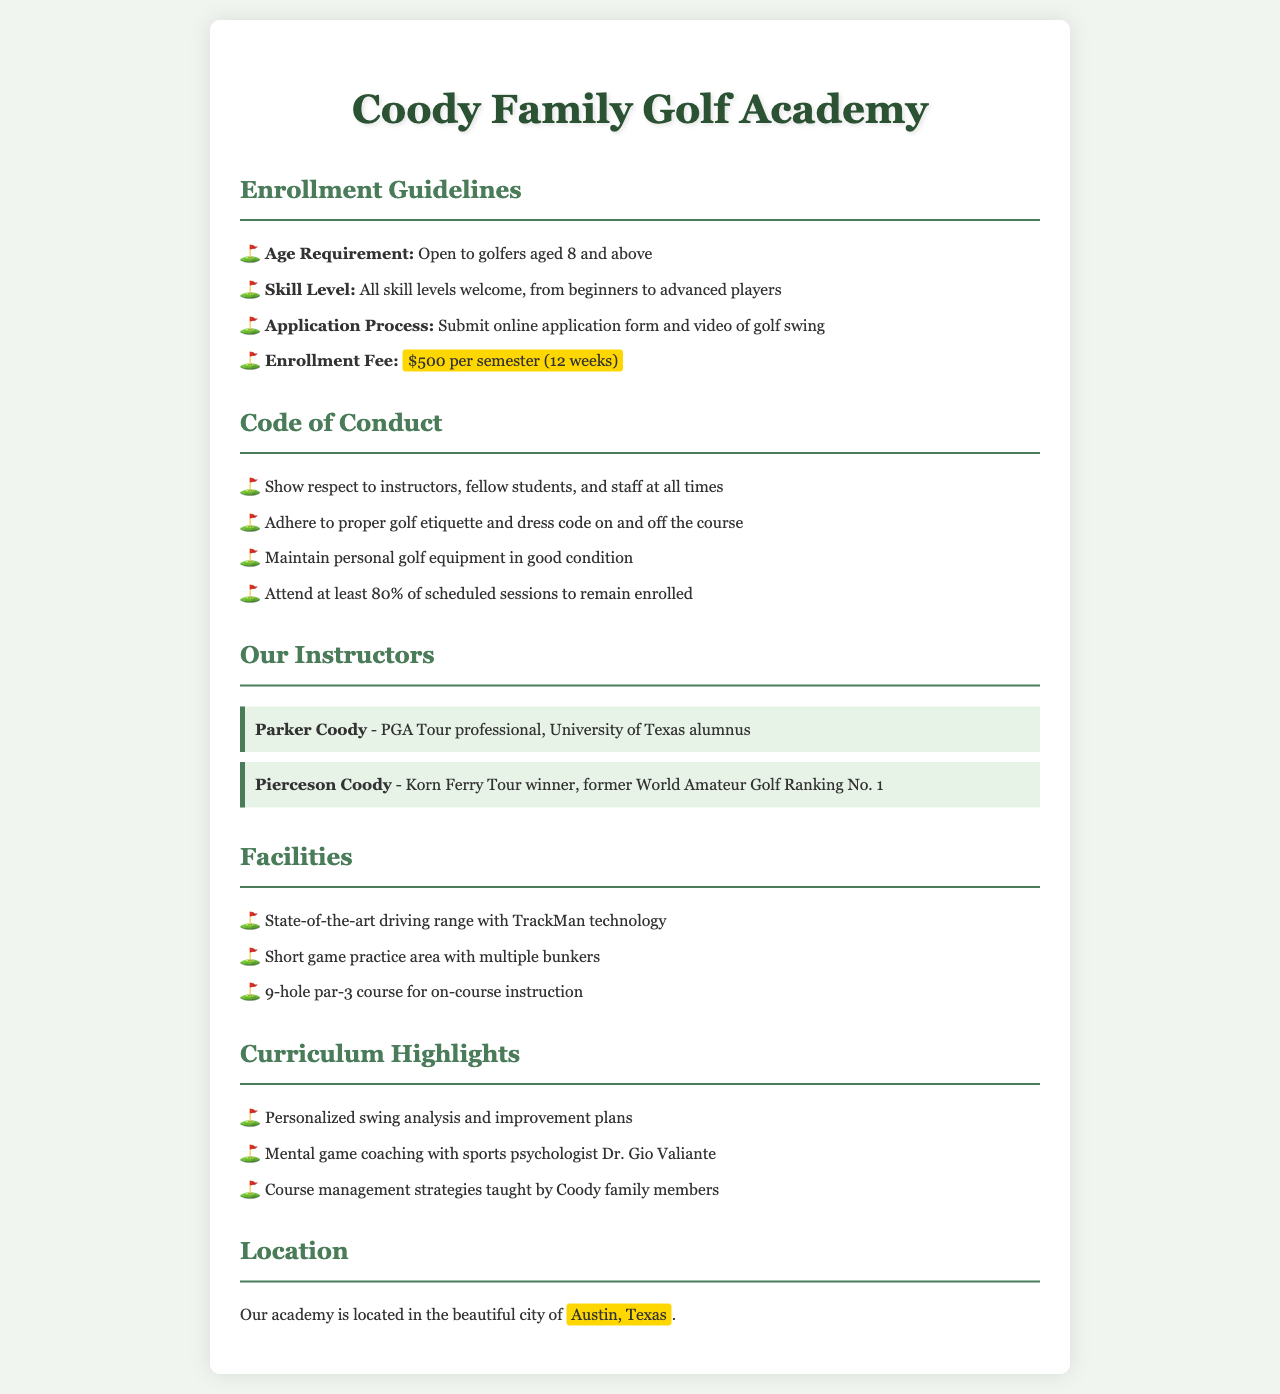What is the age requirement for enrollment? The age requirement states that it is open to golfers aged 8 and above.
Answer: 8 What is the enrollment fee per semester? The document specifies that the enrollment fee is $500 per semester.
Answer: $500 Who are the instructors at the academy? The instructors mentioned in the document are Parker Coody and Pierceson Coody.
Answer: Parker Coody, Pierceson Coody What is the minimum attendance percentage required to remain enrolled? The document states that one must attend at least 80% of scheduled sessions to remain enrolled.
Answer: 80% What technology is available at the driving range? The driving range is equipped with TrackMan technology, as stated in the document.
Answer: TrackMan technology Where is the Coody Family Golf Academy located? The location of the academy is specified as Austin, Texas.
Answer: Austin, Texas What type of course is mentioned for on-course instruction? The document mentions a 9-hole par-3 course for on-course instruction.
Answer: 9-hole par-3 course What aspect of coaching is provided by Dr. Gio Valiante? The document states that mental game coaching is provided with sports psychologist Dr. Gio Valiante.
Answer: Mental game coaching 